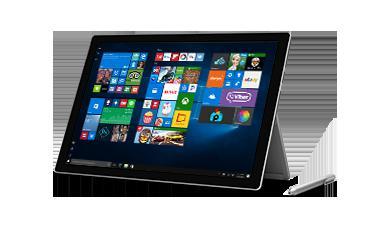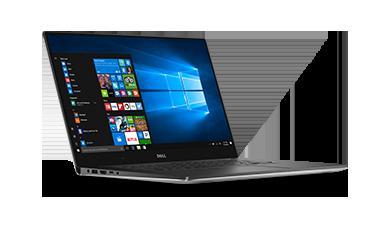The first image is the image on the left, the second image is the image on the right. For the images shown, is this caption "The right image includes a greater number of devices than the left image." true? Answer yes or no. No. 